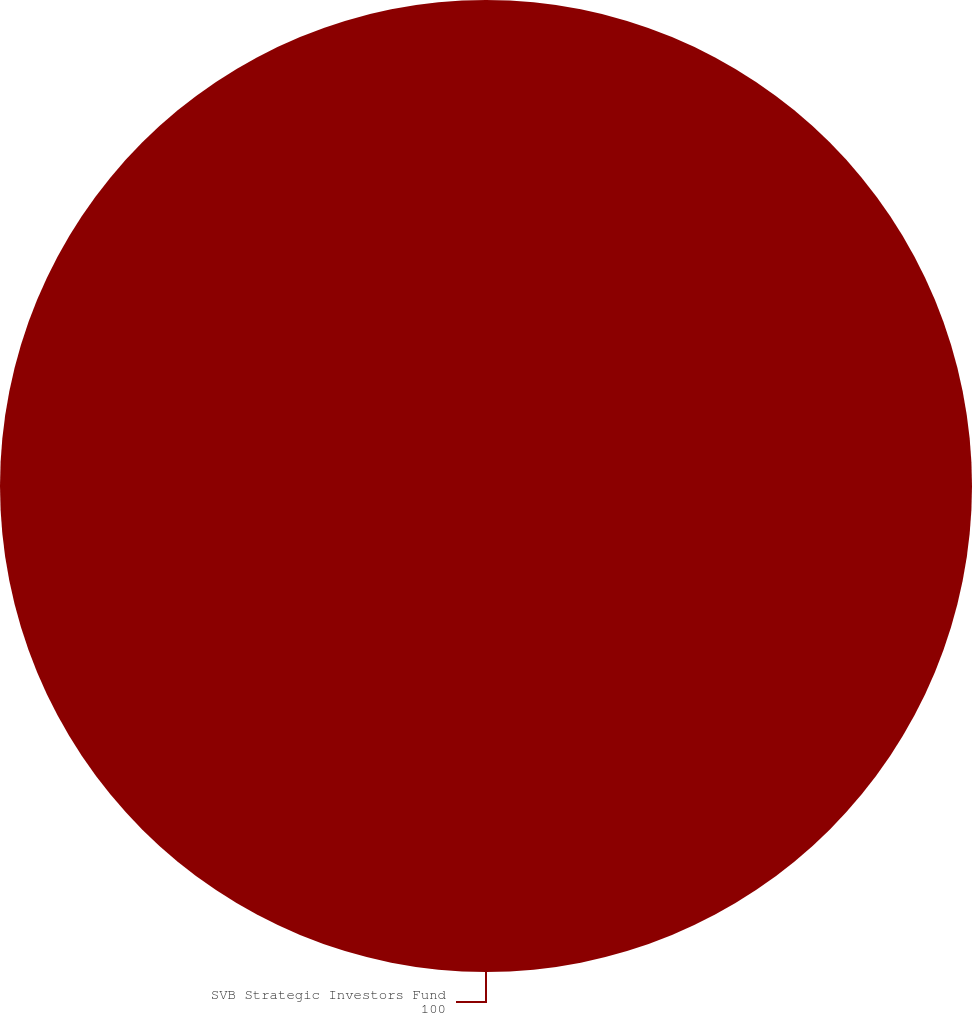<chart> <loc_0><loc_0><loc_500><loc_500><pie_chart><fcel>SVB Strategic Investors Fund<nl><fcel>100.0%<nl></chart> 